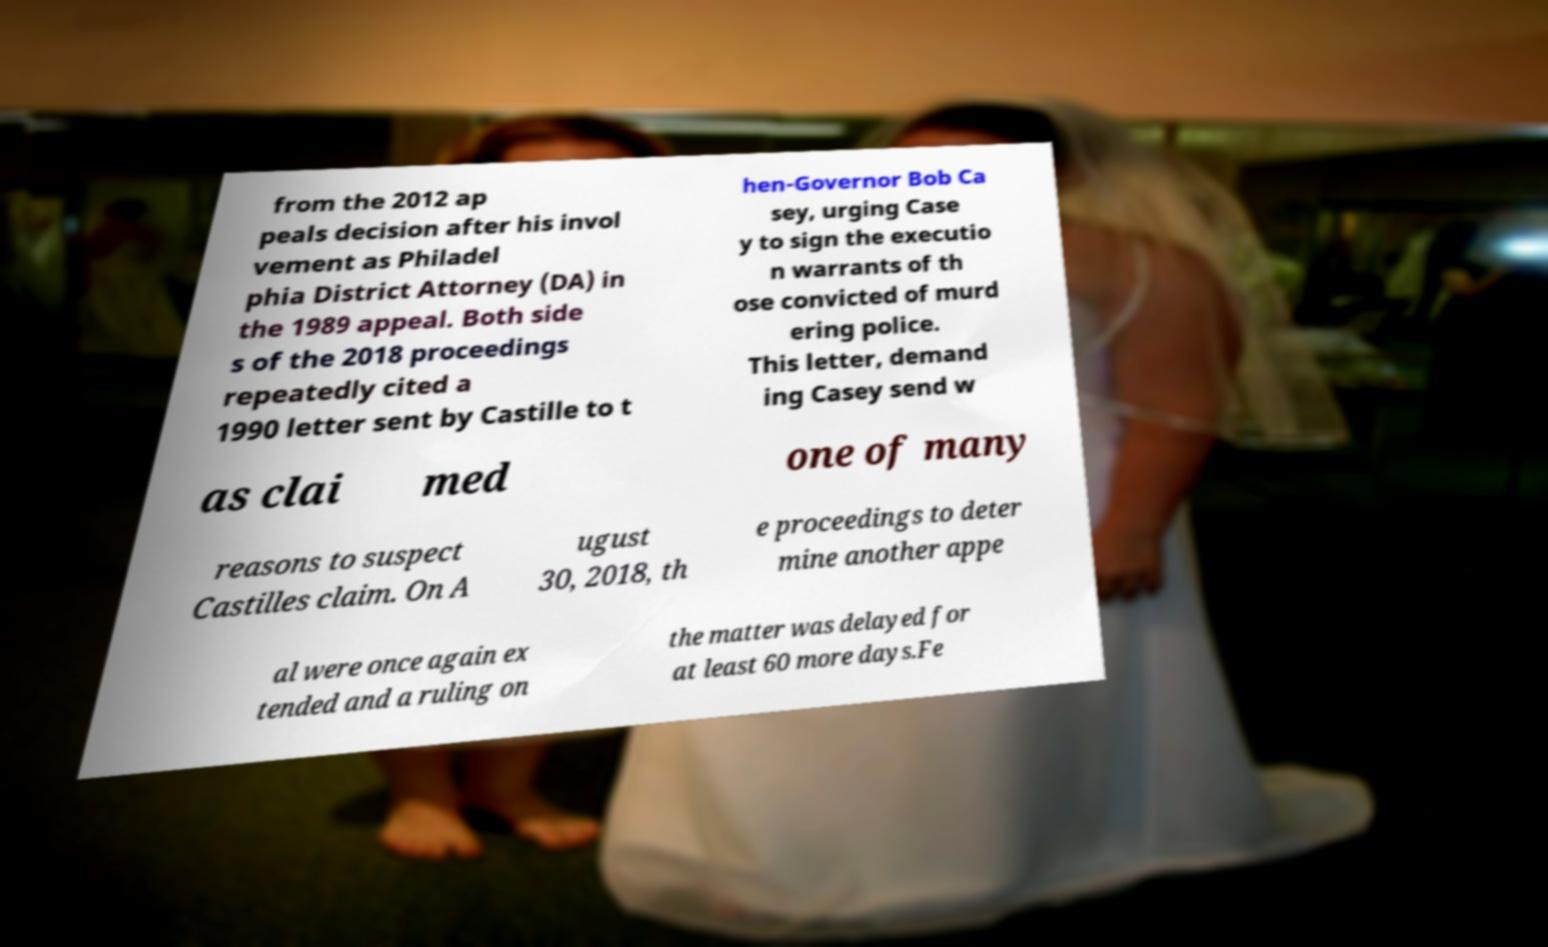Could you extract and type out the text from this image? from the 2012 ap peals decision after his invol vement as Philadel phia District Attorney (DA) in the 1989 appeal. Both side s of the 2018 proceedings repeatedly cited a 1990 letter sent by Castille to t hen-Governor Bob Ca sey, urging Case y to sign the executio n warrants of th ose convicted of murd ering police. This letter, demand ing Casey send w as clai med one of many reasons to suspect Castilles claim. On A ugust 30, 2018, th e proceedings to deter mine another appe al were once again ex tended and a ruling on the matter was delayed for at least 60 more days.Fe 